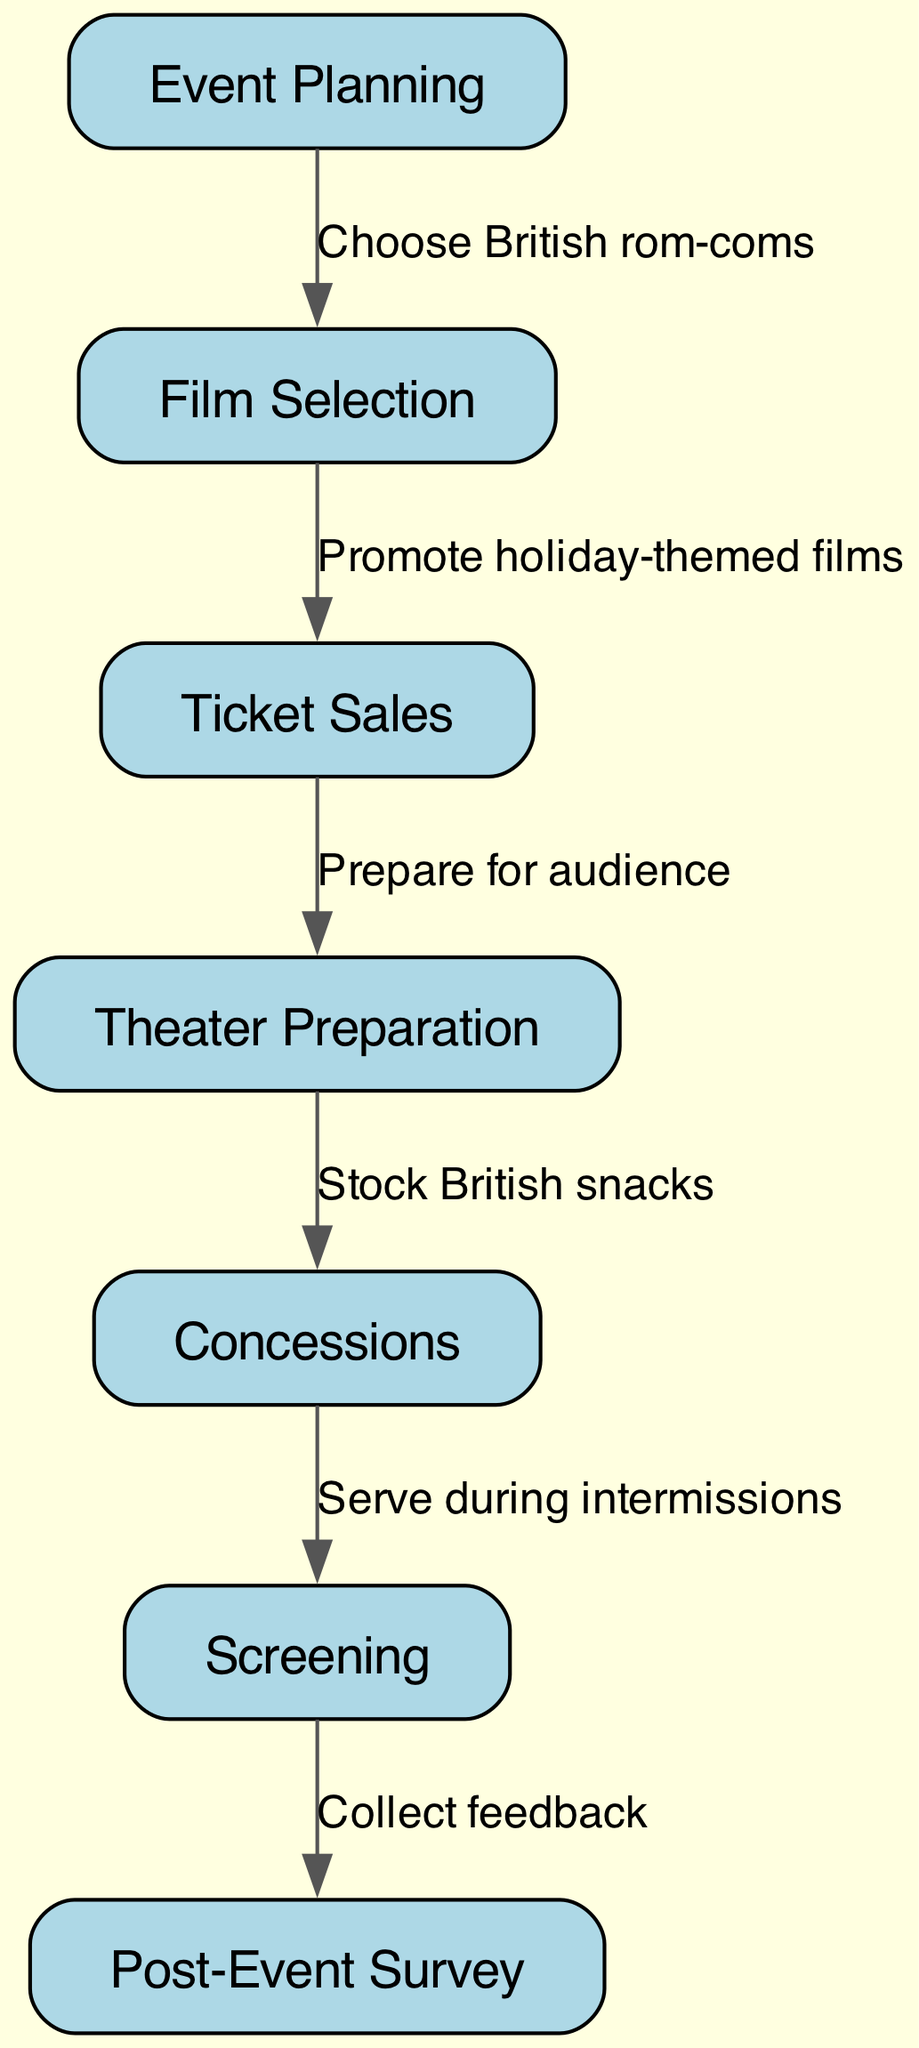What is the first step in the event flow? The first node is "Event Planning," which is the starting point of the flowchart, indicating that planning takes precedence in the event structure.
Answer: Event Planning How many nodes are in the diagram? By counting the individual elements in the "nodes" section of the diagram, we find there are 7 distinct nodes representing different steps in the event process.
Answer: 7 What is the connection between "Film Selection" and "Ticket Sales"? The edge connecting these nodes shows that "Film Selection" leads to "Ticket Sales," indicating that once films are selected, the next step is to sell tickets.
Answer: Promote holiday-themed films Which node involves audience preparation? The node "Theater Preparation" is responsible for preparing for the audience, as indicated by its position in the flowchart before concessions and the screening.
Answer: Theater Preparation What do concessions serve during? According to the diagram, "Concessions" serve during intermissions, demonstrating the timing of their service in relation to the films being screened.
Answer: Intermissions What is the last step in the process? The last node in the flowchart is "Post-Event Survey," which comes after the screening, highlighting that feedback collection is the concluding step of the event.
Answer: Post-Event Survey How does "Ticket Sales" relate to "Theater Preparation"? The diagram indicates that after ticket sales are conducted, the subsequent task is "Theater Preparation," showing a clear sequential relationship in the process flow.
Answer: Prepare for audience What type of feedback is collected in the last step? The last node, "Post-Event Survey," implies that the type of feedback collected is from the audience regarding their experience of the event.
Answer: Feedback 